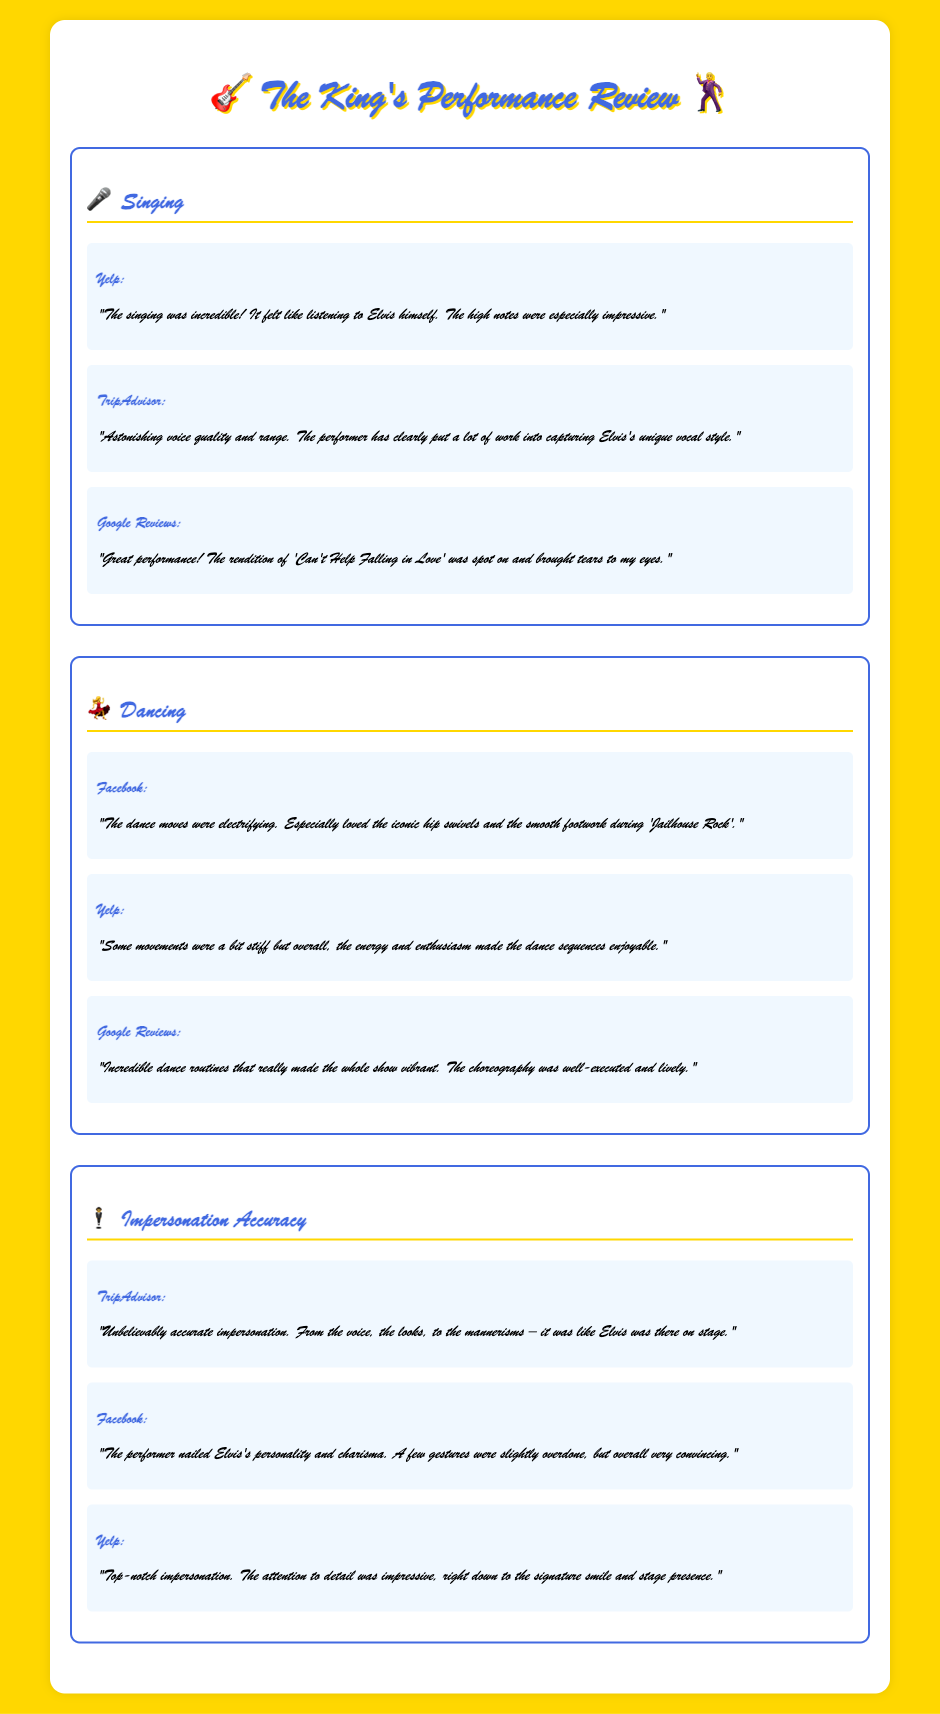What was the audience's feedback on singing? The feedback on singing highlights its incredible quality and resemblance to Elvis's voice, emphasizing particular performances like 'Can't Help Falling in Love'.
Answer: Incredible What element of the performance had a review mentioning "electrifying" moves? The review described the dance moves as electrifying, specifically praising the iconic hip swivels and smooth footwork during a song.
Answer: Dancing Which source praised the impersonation accuracy as "unbelievably accurate"? The source that described the impersonation accuracy as "unbelievably accurate" is TripAdvisor.
Answer: TripAdvisor How many reviews mentioned the quality of singing? There are three reviews listed under the singing category, discussing various aspects of the performance.
Answer: Three What did the feedback suggest about the dancing movement quality? The feedback indicated that while some movements were stiff, the overall energy and enthusiasm made the dance enjoyable.
Answer: Some movements were stiff Which song's rendition moved an audience member to tears? The song that brought tears to an audience member was 'Can't Help Falling in Love'.
Answer: Can't Help Falling in Love What aspect of the performance did the review on Facebook highlight? The Facebook review highlighted the performer's ability to capture Elvis's personality and charisma with only slight exaggerations.
Answer: Personality and charisma Which performance element received the most positive feedback overall? The performance element that received the most positive feedback overall is singing, with numerous praises on voice quality.
Answer: Singing 